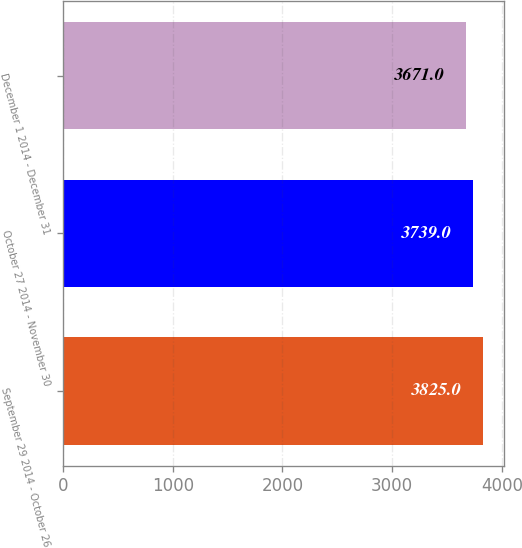Convert chart to OTSL. <chart><loc_0><loc_0><loc_500><loc_500><bar_chart><fcel>September 29 2014 - October 26<fcel>October 27 2014 - November 30<fcel>December 1 2014 - December 31<nl><fcel>3825<fcel>3739<fcel>3671<nl></chart> 